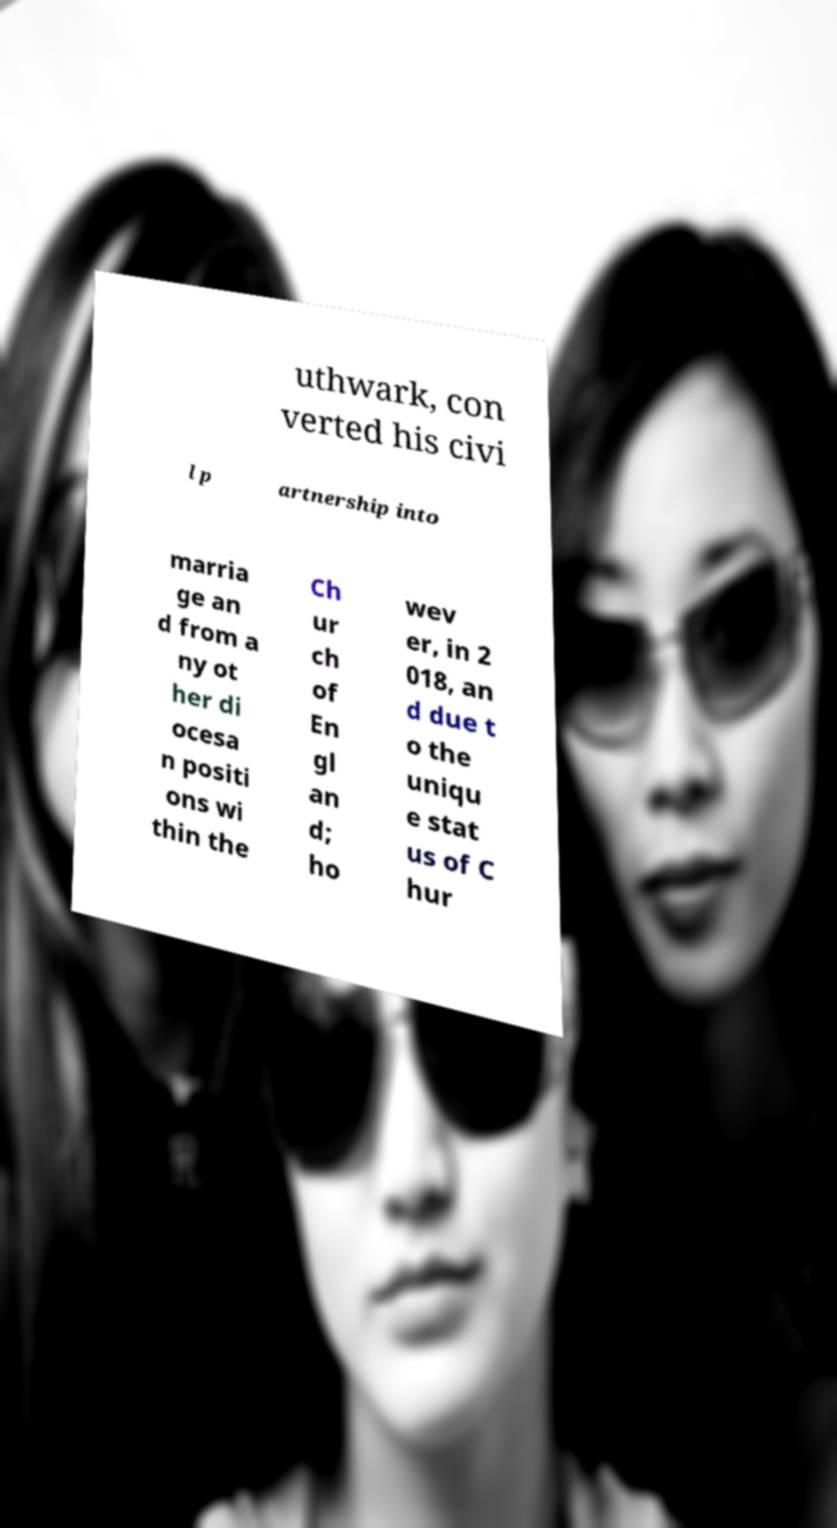There's text embedded in this image that I need extracted. Can you transcribe it verbatim? uthwark, con verted his civi l p artnership into marria ge an d from a ny ot her di ocesa n positi ons wi thin the Ch ur ch of En gl an d; ho wev er, in 2 018, an d due t o the uniqu e stat us of C hur 